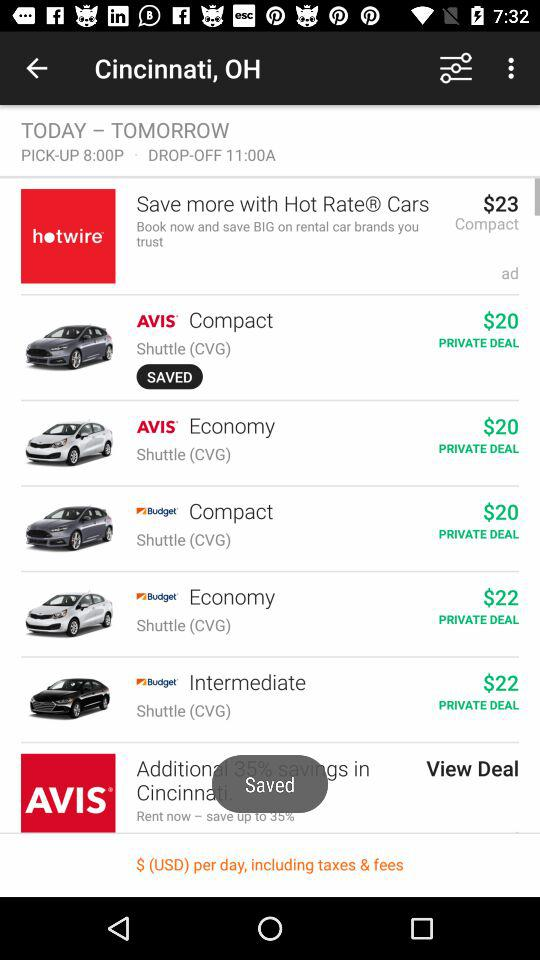How much are the taxes and fees?
When the provided information is insufficient, respond with <no answer>. <no answer> 